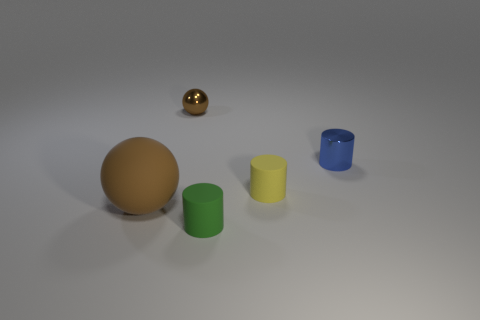There is a matte object that is the same color as the shiny ball; what is its size?
Give a very brief answer. Large. What shape is the matte thing that is the same color as the metallic sphere?
Give a very brief answer. Sphere. Are there fewer small rubber cylinders that are on the left side of the yellow rubber cylinder than tiny shiny balls?
Your response must be concise. No. Is the metal cylinder the same color as the large rubber object?
Your response must be concise. No. The yellow cylinder has what size?
Provide a succinct answer. Small. How many rubber spheres are the same color as the shiny cylinder?
Offer a very short reply. 0. There is a object behind the blue shiny cylinder behind the brown rubber object; are there any small yellow objects behind it?
Your answer should be very brief. No. What shape is the green matte thing that is the same size as the brown metal object?
Offer a very short reply. Cylinder. What number of large things are either blue cylinders or yellow rubber things?
Your response must be concise. 0. The small cylinder that is made of the same material as the tiny green thing is what color?
Offer a very short reply. Yellow. 